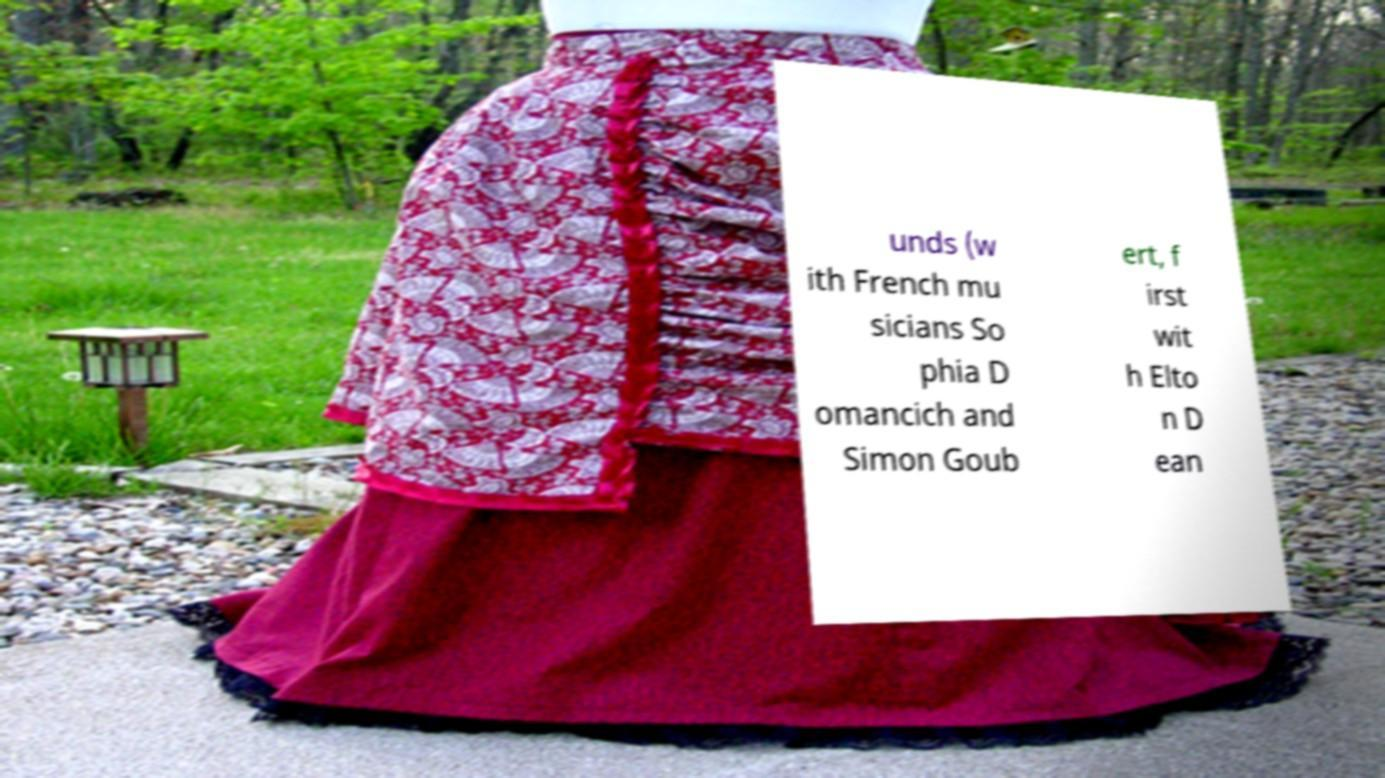Please read and relay the text visible in this image. What does it say? unds (w ith French mu sicians So phia D omancich and Simon Goub ert, f irst wit h Elto n D ean 